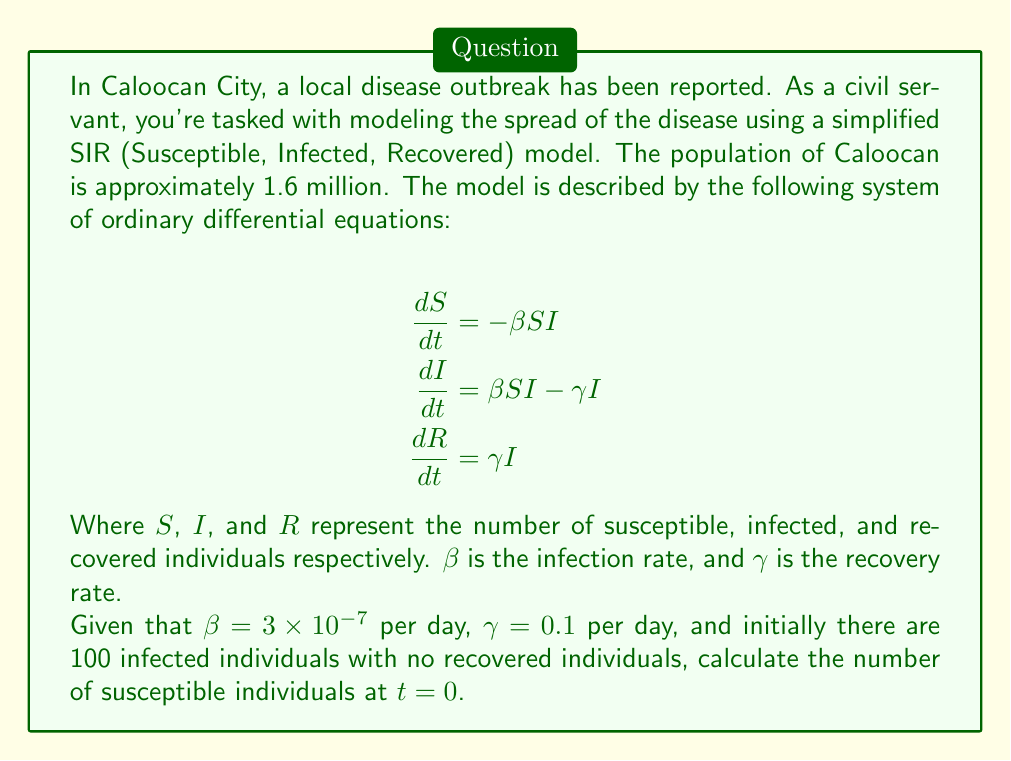Show me your answer to this math problem. To solve this problem, we need to use the information given and the properties of the SIR model:

1) First, recall that in the SIR model, the total population $N$ remains constant:

   $N = S(t) + I(t) + R(t)$

2) We're given that the population of Caloocan is approximately 1.6 million:

   $N = 1,600,000$

3) At $t = 0$, we're told that there are 100 infected individuals and no recovered individuals:

   $I(0) = 100$
   $R(0) = 0$

4) To find $S(0)$, we can use the equation from step 1:

   $S(0) + I(0) + R(0) = N$

5) Substituting the known values:

   $S(0) + 100 + 0 = 1,600,000$

6) Solving for $S(0)$:

   $S(0) = 1,600,000 - 100 = 1,599,900$

Therefore, the number of susceptible individuals at $t = 0$ is 1,599,900.
Answer: $S(0) = 1,599,900$ 